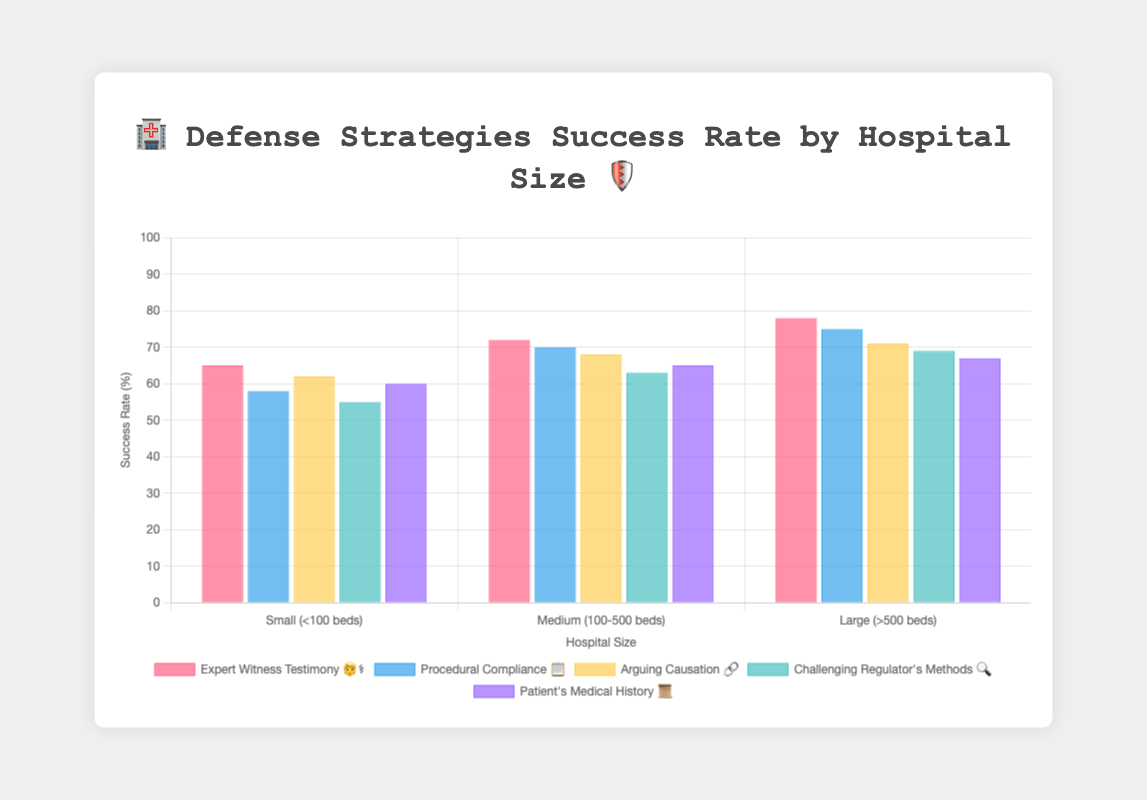What is the title of the figure? The title is prominently displayed at the top of the figure. It reads "🏥 Defense Strategies Success Rate by Hospital Size 🛡️".
Answer: "🏥 Defense Strategies Success Rate by Hospital Size 🛡️" Which hospital size has the highest success rate for "Expert Witness Testimony 🧑‍⚕️"? By looking at the bars representing "Expert Witness Testimony 🧑‍⚕️", the highest success rate is for "Large (>500 beds)" hospitals.
Answer: Large (>500 beds) Which defense strategy has the lowest success rate for Small hospitals? By observing the bars corresponding to Small hospitals, "Challenging Regulator's Methods 🔍" has the lowest success rate.
Answer: Challenging Regulator's Methods 🔍 What is the difference in success rate between 'Procedural Compliance 📋' and 'Patient's Medical History 📜' for Medium hospitals? For Medium hospitals, the success rates are 70% for "Procedural Compliance 📋" and 65% for "Patient's Medical History 📜". The difference is 70% - 65% = 5%.
Answer: 5% Which defense strategy has the most consistent success rate across all hospital sizes? By comparing the success rates of all strategies across the hospital sizes, "Arguing Causation 🔗" has relatively close values: 62%, 68%, and 71%.
Answer: Arguing Causation 🔗 What is the combined success rate for Large hospitals using 'Challenging Regulator's Methods 🔍' and 'Expert Witness Testimony 🧑‍⚕️'? The success rates for Large hospitals for the two strategies are 69% and 78% respectively. Summing them gives 69% + 78% = 147%.
Answer: 147% Which hospital size shows the greatest improvement in success rate for "Procedural Compliance 📋" compared to "Challenging Regulator's Methods 🔍"? To determine this, we compare the difference in success rates for each hospital size. Small: 58% - 55% = 3%, Medium: 70% - 63% = 7%, Large: 75% - 69% = 6%. The highest improvement is seen in Medium hospitals.
Answer: Medium (100-500 beds) For Medium hospitals, what is the average success rate across all the listed defense strategies? The success rates for Medium hospitals are 72%, 70%, 68%, 63%, and 65%. The average is calculated as (72 + 70 + 68 + 63 + 65) / 5 = 67.6%.
Answer: 67.6% What two defense strategies have the closest success rates for Small hospitals? The success rates for Small hospitals are as follows: 65% (Expert Witness Testimony 🧑‍⚕️), 58% (Procedural Compliance 📋), 62% (Arguing Causation 🔗), 55% (Challenging Regulator's Methods 🔍), and 60% (Patient's Medical History 📜). The closest pair is "Procedural Compliance 📋" (58%) and "Challenging Regulator's Methods 🔍" (55%), with a difference of 3%.
Answer: Procedural Compliance 📋 and Challenging Regulator's Methods 🔍 What is the visual appearance (color) of the bars representing "Arguing Causation 🔗"? The bars for "Arguing Causation 🔗" follow a specific color scheme in the figure. They are displayed in a teal-like color, both in background and border.
Answer: Teal-like color 